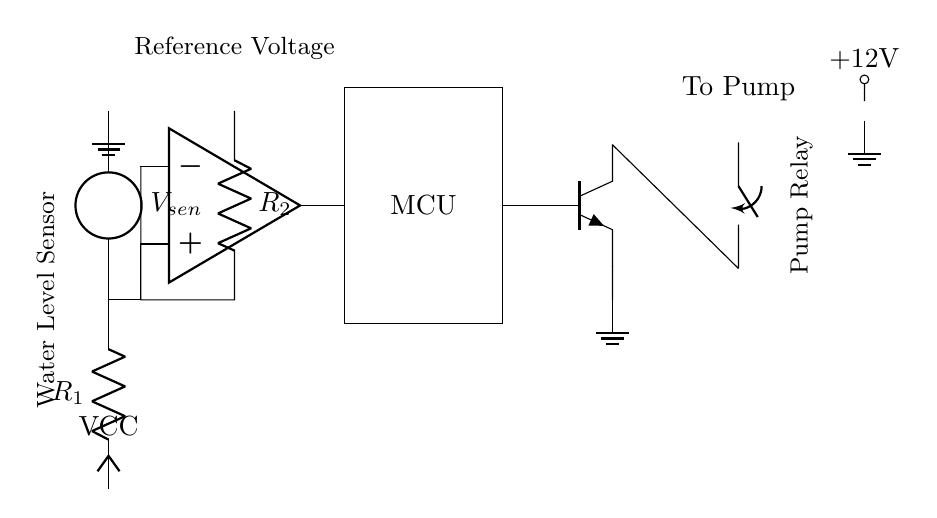What is the component labelled as VCC? VCC represents the power supply voltage for the circuit, providing the necessary energy for the components to function.
Answer: Power supply What does the water level sensor do in this circuit? The water level sensor detects the water level and sends a signal to the comparator to determine when the pump should operate, acting as a critical safety and operational feature.
Answer: Detects water level What is the reference voltage used for in this circuit? The reference voltage is used by the comparator to compare the voltage from the water level sensor, determining whether to turn on the pump based on the water level detected.
Answer: Comparator reference Which component functions as the relay driver in the circuit? The relay driver, represented as an npn transistor, activates the relay when the microcontroller sends a signal, allowing the pump to be controlled with low power.
Answer: NPN transistor What is the purpose of the relay in this circuit? The relay allows the low power control signal from the microcontroller to switch on the higher power required to operate the water pump, thus enabling control over the pump's operation without needing high current through the microcontroller.
Answer: Control pump operation How many resistors are present in the circuit diagram? There are two resistors, R1 and R2, used to control the voltage levels in the circuit for the sensor and comparator operations.
Answer: Two resistors What is the voltage supply rating for the circuit? The circuit is powered by a battery with a voltage rating of plus 12 volts, providing power to the components.
Answer: Plus 12 volts 